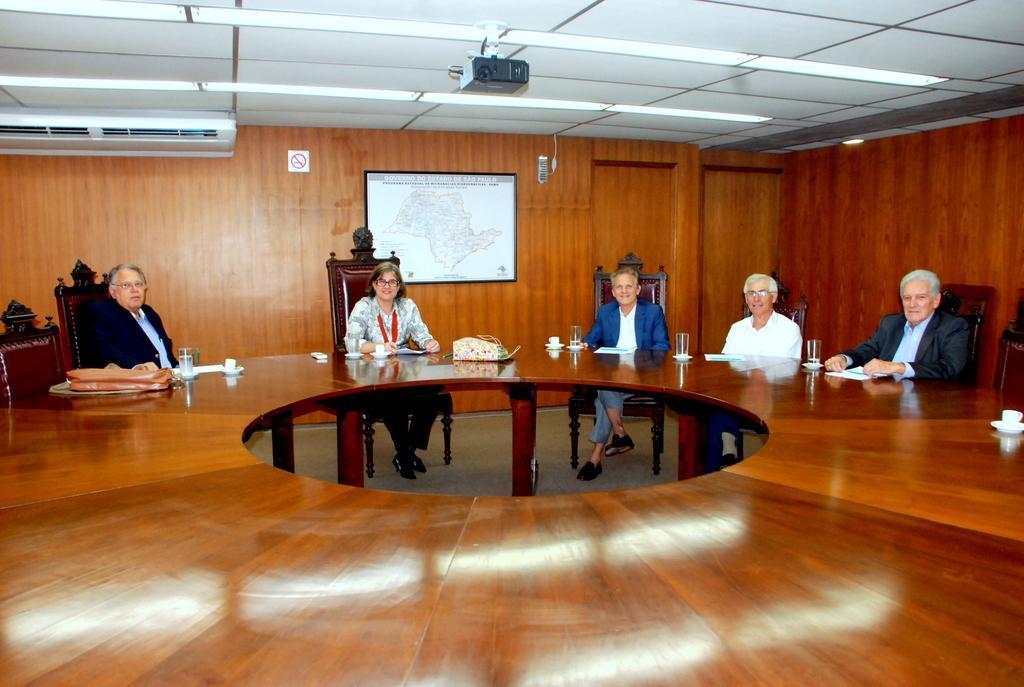Please provide a concise description of this image. There are 5 people sitting on a chair around a big table. Behind them there is a wall,frame,AC. On the roof top there is a projector. 